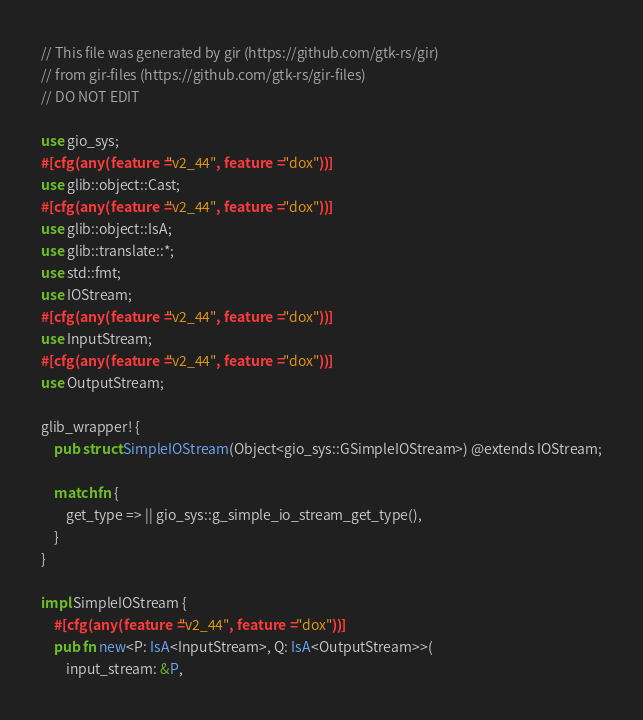<code> <loc_0><loc_0><loc_500><loc_500><_Rust_>// This file was generated by gir (https://github.com/gtk-rs/gir)
// from gir-files (https://github.com/gtk-rs/gir-files)
// DO NOT EDIT

use gio_sys;
#[cfg(any(feature = "v2_44", feature = "dox"))]
use glib::object::Cast;
#[cfg(any(feature = "v2_44", feature = "dox"))]
use glib::object::IsA;
use glib::translate::*;
use std::fmt;
use IOStream;
#[cfg(any(feature = "v2_44", feature = "dox"))]
use InputStream;
#[cfg(any(feature = "v2_44", feature = "dox"))]
use OutputStream;

glib_wrapper! {
    pub struct SimpleIOStream(Object<gio_sys::GSimpleIOStream>) @extends IOStream;

    match fn {
        get_type => || gio_sys::g_simple_io_stream_get_type(),
    }
}

impl SimpleIOStream {
    #[cfg(any(feature = "v2_44", feature = "dox"))]
    pub fn new<P: IsA<InputStream>, Q: IsA<OutputStream>>(
        input_stream: &P,</code> 